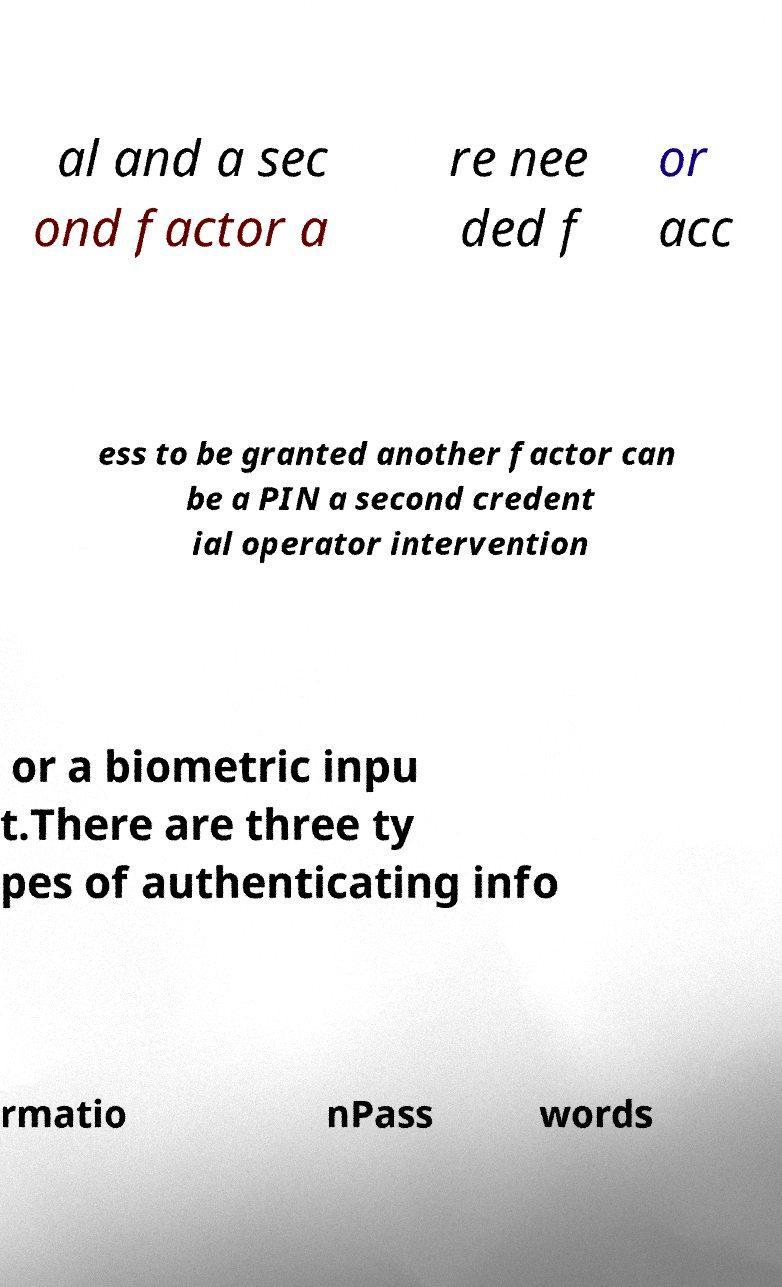Can you accurately transcribe the text from the provided image for me? al and a sec ond factor a re nee ded f or acc ess to be granted another factor can be a PIN a second credent ial operator intervention or a biometric inpu t.There are three ty pes of authenticating info rmatio nPass words 